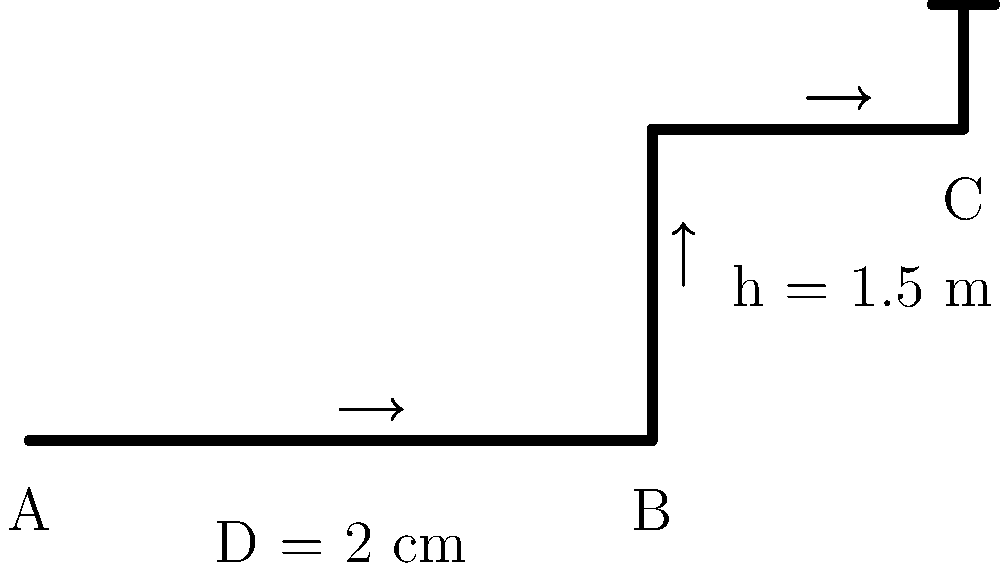In the household plumbing system shown above, water flows from point A to point C. The pipe has a constant diameter of 2 cm, and the vertical rise from B to C is 1.5 m. If the water pressure at point A is 300 kPa, what is the approximate flow rate in liters per minute? Assume smooth pipes and neglect minor losses. To solve this problem, we'll use the Bernoulli equation and the continuity equation. Let's go through this step-by-step:

1. Apply Bernoulli's equation between points A and C:

   $$\frac{P_A}{\rho g} + \frac{v_A^2}{2g} + z_A = \frac{P_C}{\rho g} + \frac{v_C^2}{2g} + z_C + h_f$$

   Where $h_f$ is the head loss due to friction.

2. Assume $v_A = v_C = v$ (constant diameter pipe), and $z_A = 0$, $z_C = 1.5$ m:

   $$\frac{300000}{\rho g} + \frac{v^2}{2g} + 0 = \frac{P_C}{\rho g} + \frac{v^2}{2g} + 1.5 + h_f$$

3. The head loss can be calculated using the Darcy-Weisbach equation:

   $$h_f = f \frac{L}{D} \frac{v^2}{2g}$$

   Where $f$ is the friction factor, $L$ is the pipe length, and $D$ is the pipe diameter.

4. Estimate $f = 0.02$ for smooth pipes and $L = 3$ m (approximate total length):

   $$h_f = 0.02 \cdot \frac{3}{0.02} \cdot \frac{v^2}{2g} = 1.5 \frac{v^2}{2g}$$

5. Substitute this into the Bernoulli equation:

   $$\frac{300000}{\rho g} = \frac{P_C}{\rho g} + 1.5 + 1.5 \frac{v^2}{2g}$$

6. Assume $P_C = 0$ (open to atmosphere) and solve for $v$:

   $$v = \sqrt{\frac{2g(300000/(\rho g) - 1.5)}{2.5}} \approx 10.8 \text{ m/s}$$

7. Calculate the flow rate:

   $$Q = vA = v \cdot \frac{\pi D^2}{4} = 10.8 \cdot \frac{\pi (0.02)^2}{4} = 0.0034 \text{ m}^3/\text{s}$$

8. Convert to liters per minute:

   $$Q = 0.0034 \text{ m}^3/\text{s} \cdot \frac{1000 \text{ L}}{\text{m}^3} \cdot \frac{60 \text{ s}}{\text{min}} \approx 204 \text{ L/min}$$
Answer: 204 L/min 